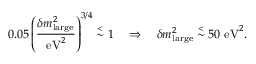Convert formula to latex. <formula><loc_0><loc_0><loc_500><loc_500>0 . 0 5 \left ( { \frac { \delta m _ { l \arg e } ^ { 2 } } { e V ^ { 2 } } } \right ) ^ { 3 / 4 } \stackrel { < } { \sim } 1 \quad \Rightarrow \quad \delta m _ { l \arg e } ^ { 2 } \stackrel { < } { \sim } 5 0 \ e V ^ { 2 } .</formula> 